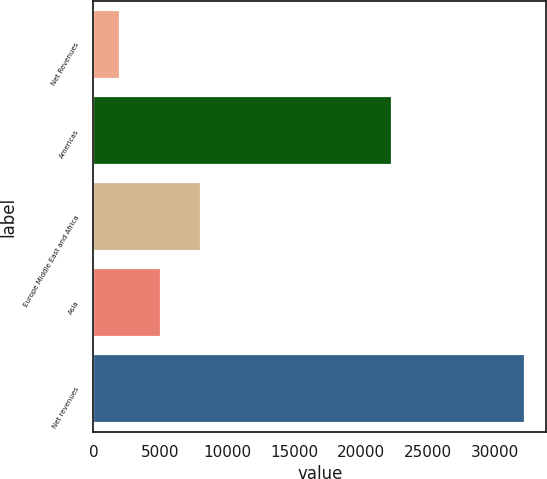Convert chart to OTSL. <chart><loc_0><loc_0><loc_500><loc_500><bar_chart><fcel>Net Revenues<fcel>Americas<fcel>Europe Middle East and Africa<fcel>Asia<fcel>Net revenues<nl><fcel>2011<fcel>22306<fcel>8056<fcel>5033.5<fcel>32236<nl></chart> 